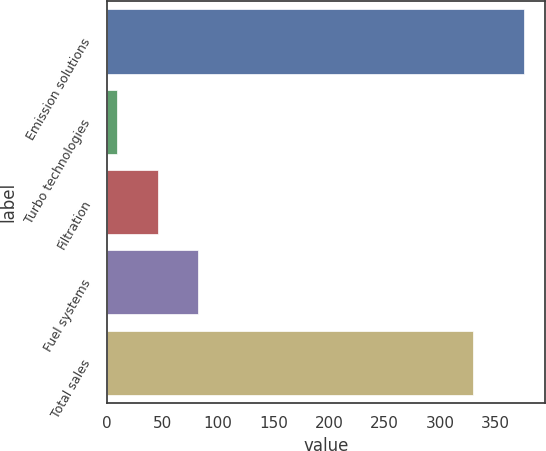Convert chart. <chart><loc_0><loc_0><loc_500><loc_500><bar_chart><fcel>Emission solutions<fcel>Turbo technologies<fcel>Filtration<fcel>Fuel systems<fcel>Total sales<nl><fcel>376<fcel>9<fcel>45.7<fcel>82.4<fcel>330<nl></chart> 